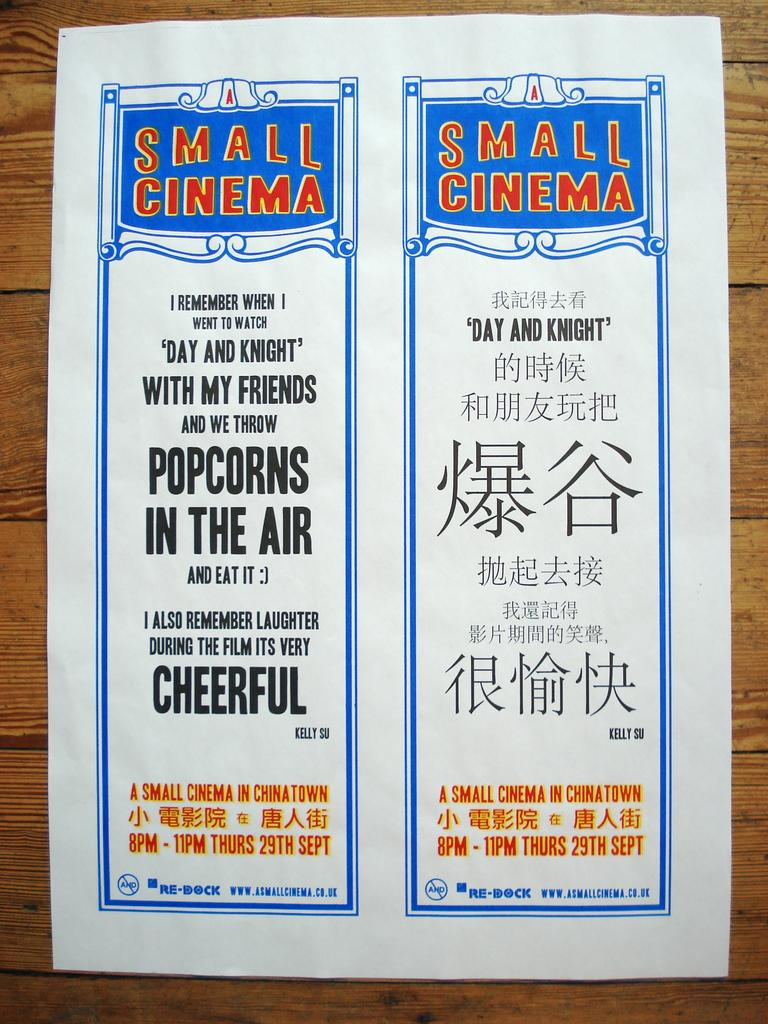<image>
Summarize the visual content of the image. A posted sign for a small cinema in Chinatown displays their hours for the 29th of September. 